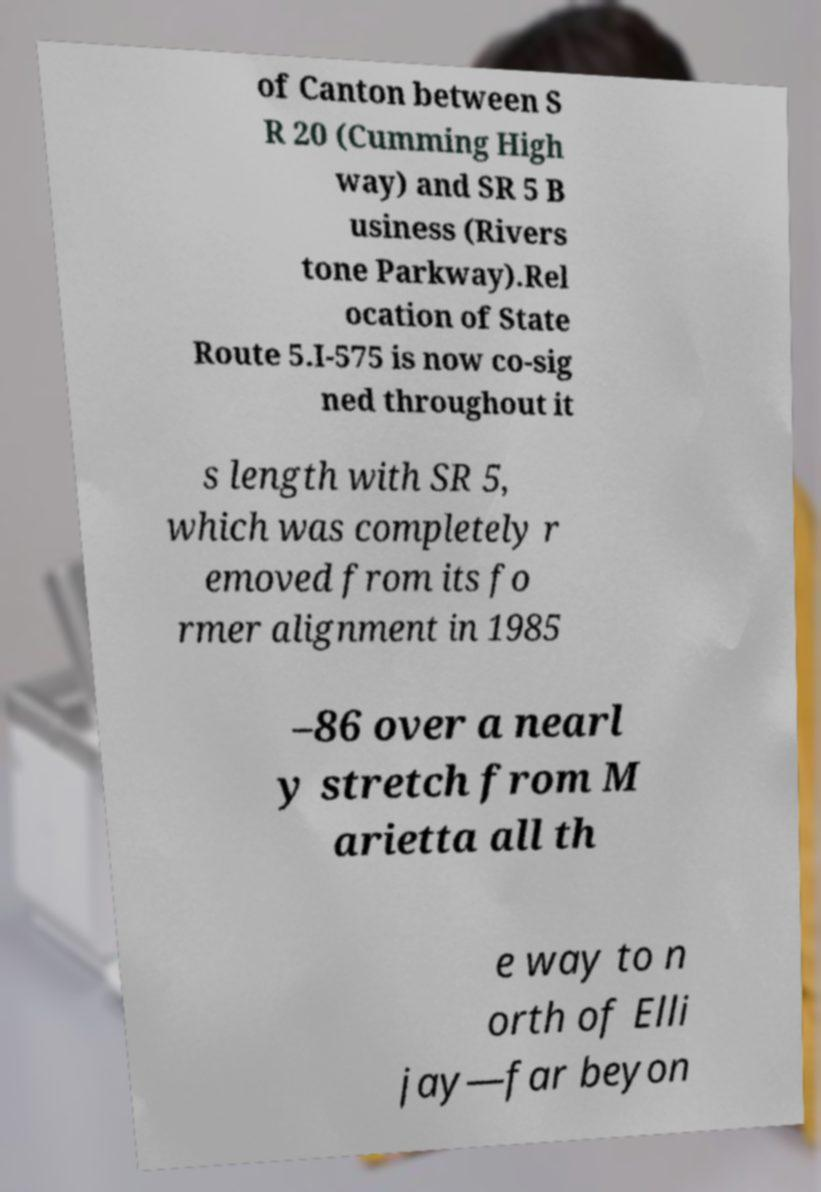What messages or text are displayed in this image? I need them in a readable, typed format. of Canton between S R 20 (Cumming High way) and SR 5 B usiness (Rivers tone Parkway).Rel ocation of State Route 5.I-575 is now co-sig ned throughout it s length with SR 5, which was completely r emoved from its fo rmer alignment in 1985 –86 over a nearl y stretch from M arietta all th e way to n orth of Elli jay—far beyon 